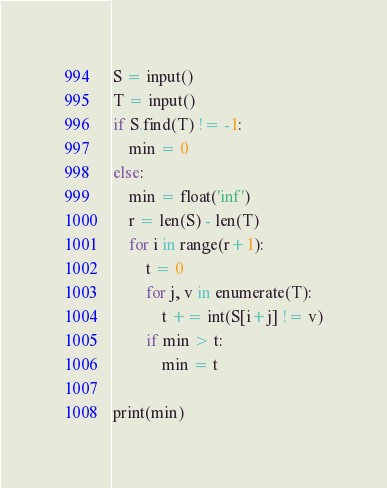Convert code to text. <code><loc_0><loc_0><loc_500><loc_500><_Python_>S = input()
T = input()
if S.find(T) != -1:
    min = 0
else:
    min = float('inf')
    r = len(S) - len(T)
    for i in range(r+1):
        t = 0
        for j, v in enumerate(T):
            t += int(S[i+j] != v)
        if min > t:
            min = t

print(min)
</code> 